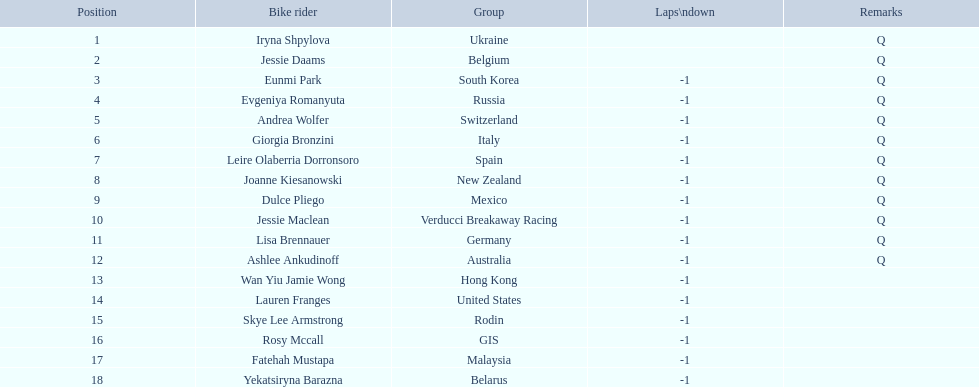How many consecutive notes are there? 12. 